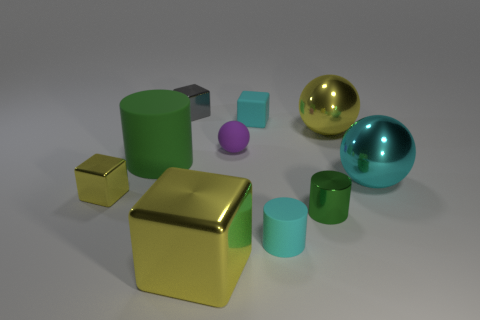Subtract all brown cubes. Subtract all brown spheres. How many cubes are left? 4 Subtract all blocks. How many objects are left? 6 Subtract all matte cylinders. Subtract all small cylinders. How many objects are left? 6 Add 8 small rubber blocks. How many small rubber blocks are left? 9 Add 1 yellow objects. How many yellow objects exist? 4 Subtract 1 cyan balls. How many objects are left? 9 